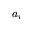Convert formula to latex. <formula><loc_0><loc_0><loc_500><loc_500>a _ { i }</formula> 